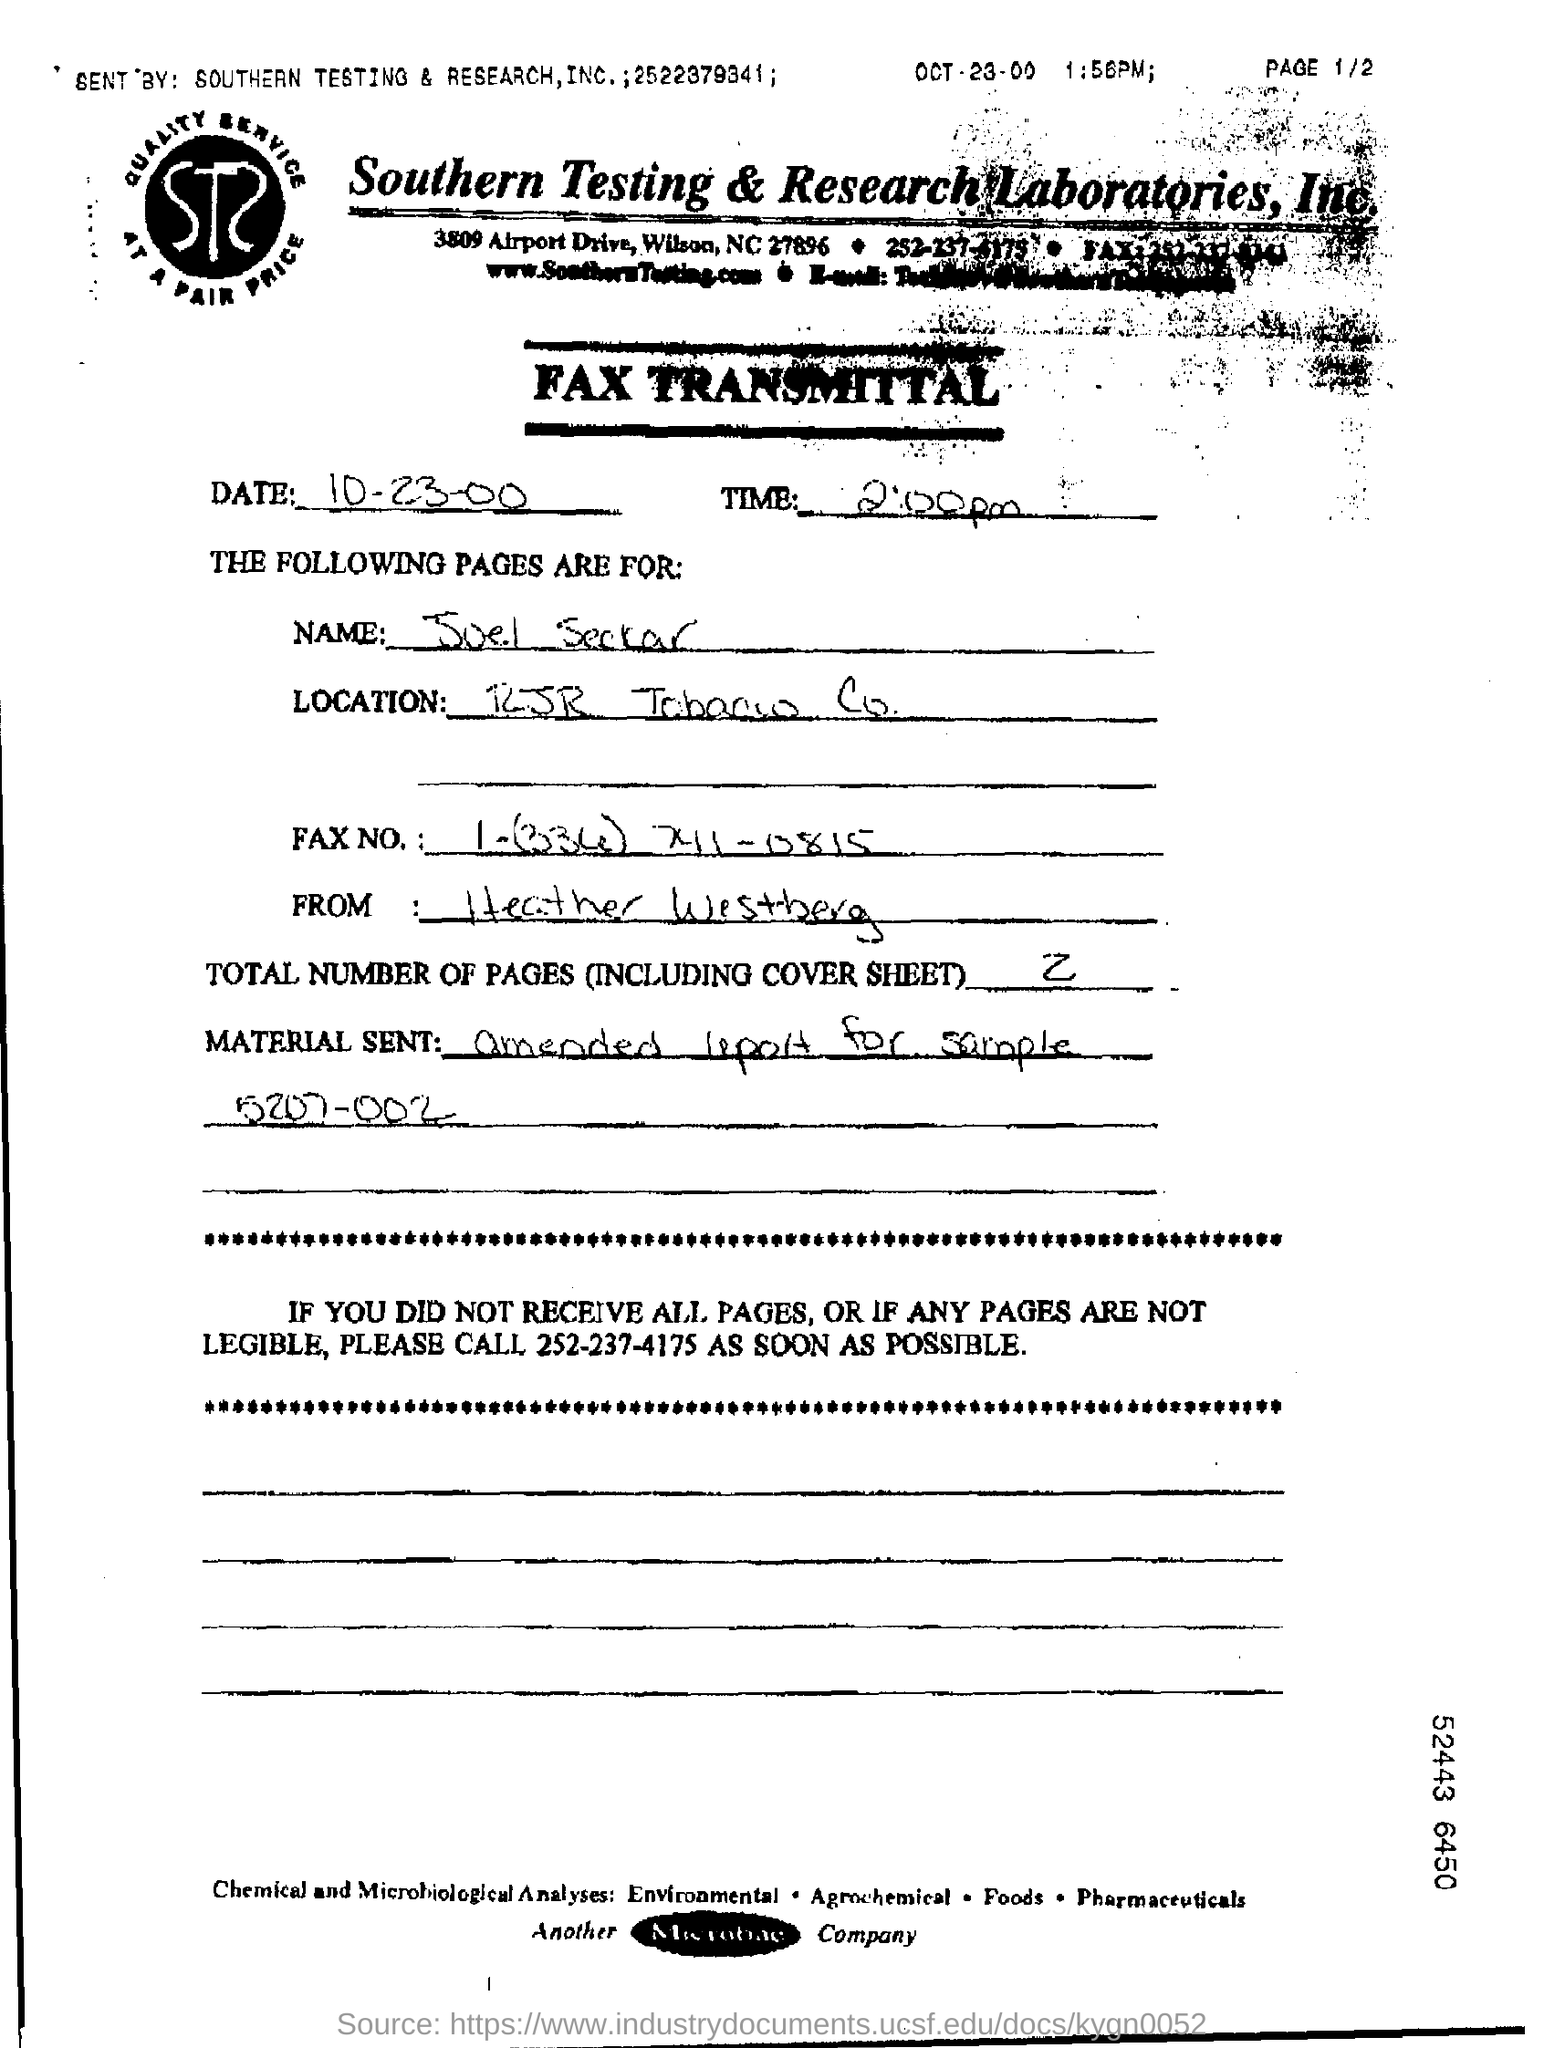Point out several critical features in this image. The total number of pages, including the cover sheet, is two. The material sent in the fax is an amended report for sample 5207-002. 